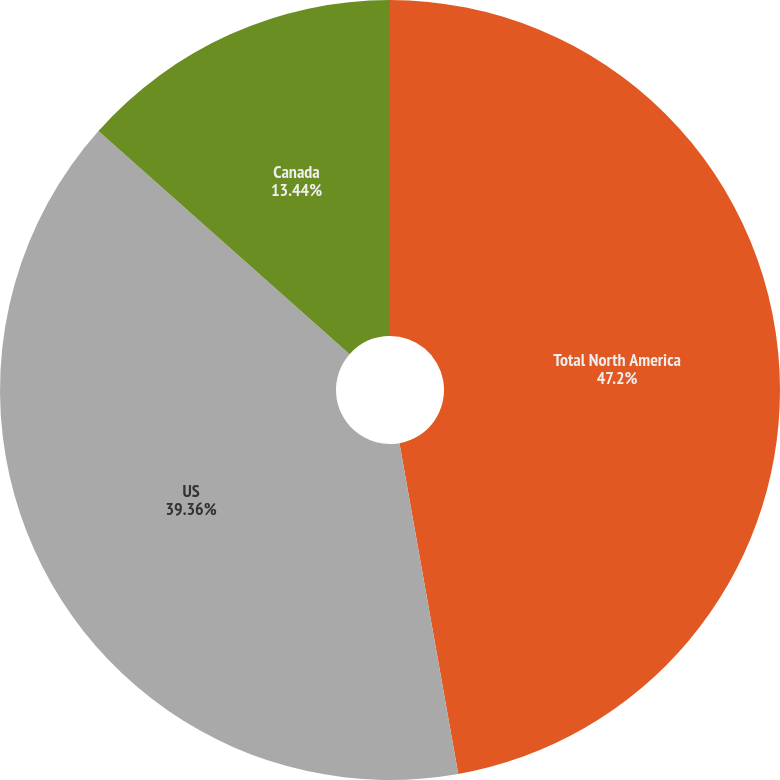<chart> <loc_0><loc_0><loc_500><loc_500><pie_chart><fcel>Total North America<fcel>US<fcel>Canada<nl><fcel>47.2%<fcel>39.36%<fcel>13.44%<nl></chart> 